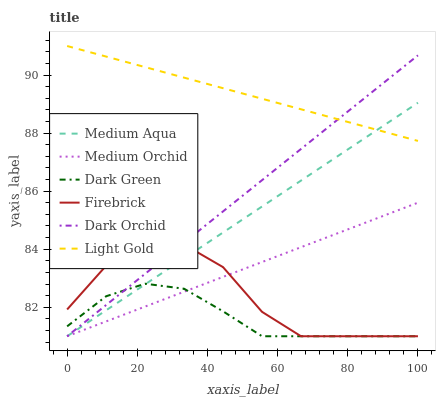Does Dark Green have the minimum area under the curve?
Answer yes or no. Yes. Does Light Gold have the maximum area under the curve?
Answer yes or no. Yes. Does Medium Orchid have the minimum area under the curve?
Answer yes or no. No. Does Medium Orchid have the maximum area under the curve?
Answer yes or no. No. Is Medium Orchid the smoothest?
Answer yes or no. Yes. Is Firebrick the roughest?
Answer yes or no. Yes. Is Dark Orchid the smoothest?
Answer yes or no. No. Is Dark Orchid the roughest?
Answer yes or no. No. Does Firebrick have the lowest value?
Answer yes or no. Yes. Does Light Gold have the lowest value?
Answer yes or no. No. Does Light Gold have the highest value?
Answer yes or no. Yes. Does Medium Orchid have the highest value?
Answer yes or no. No. Is Dark Green less than Light Gold?
Answer yes or no. Yes. Is Light Gold greater than Firebrick?
Answer yes or no. Yes. Does Medium Orchid intersect Medium Aqua?
Answer yes or no. Yes. Is Medium Orchid less than Medium Aqua?
Answer yes or no. No. Is Medium Orchid greater than Medium Aqua?
Answer yes or no. No. Does Dark Green intersect Light Gold?
Answer yes or no. No. 